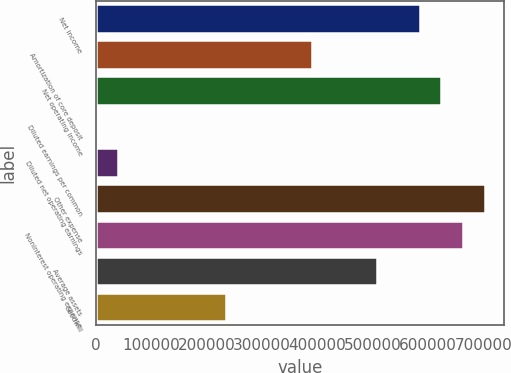<chart> <loc_0><loc_0><loc_500><loc_500><bar_chart><fcel>Net income<fcel>Amortization of core deposit<fcel>Net operating income<fcel>Diluted earnings per common<fcel>Diluted net operating earnings<fcel>Other expense<fcel>Noninterest operating expense<fcel>Average assets<fcel>Goodwill<nl><fcel>584950<fcel>389967<fcel>623946<fcel>1.3<fcel>38997.9<fcel>701940<fcel>662943<fcel>506957<fcel>233981<nl></chart> 